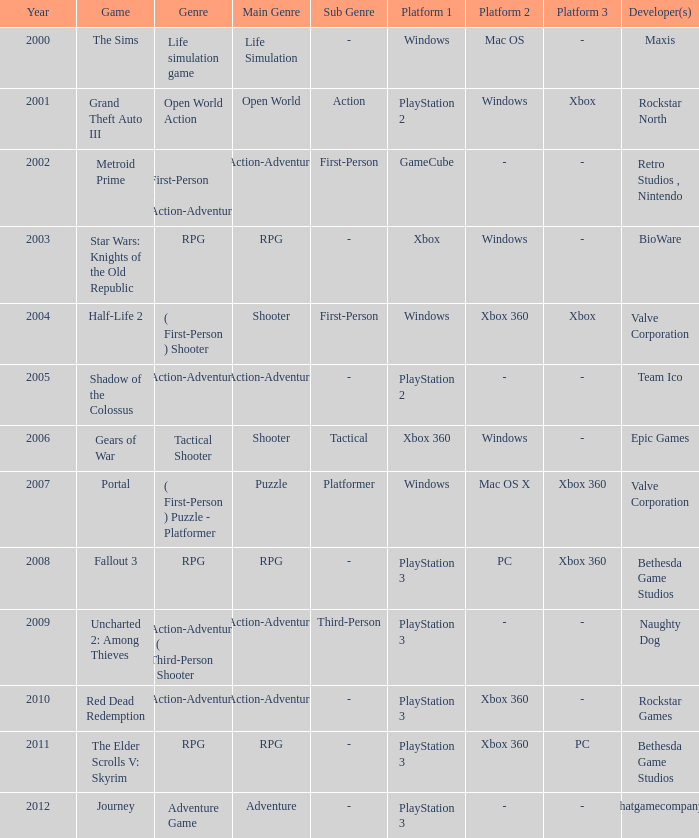What game was in 2005? Shadow of the Colossus. 